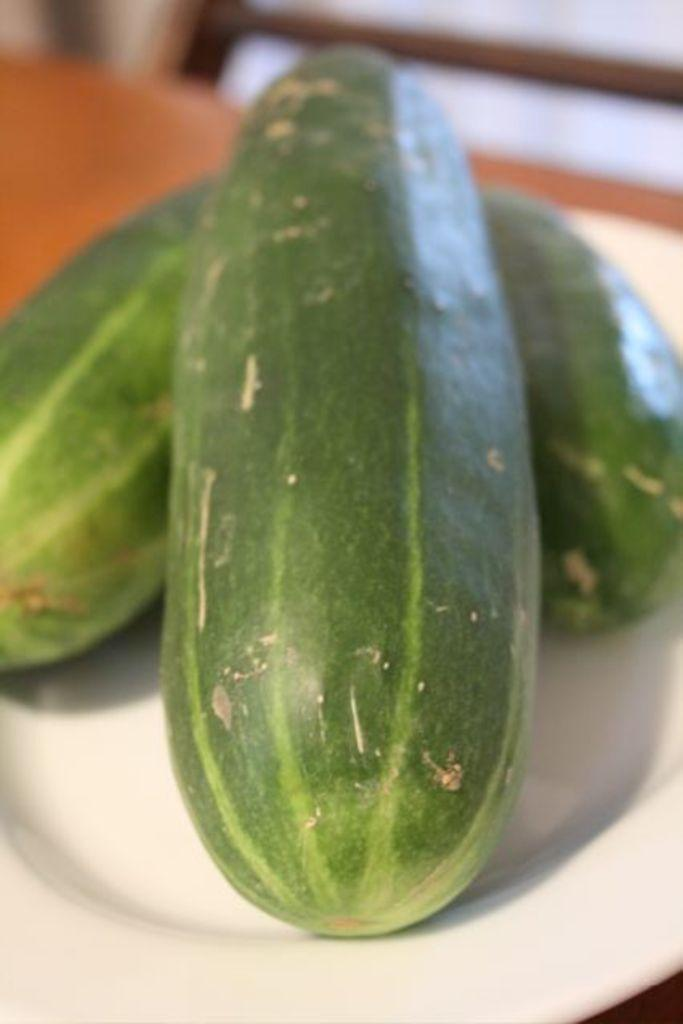What type of food is on the plate in the image? There are cucumbers on a plate in the image. Can you describe the background of the image? The background of the image is blurred. What type of chain is draped over the cucumbers in the image? There is no chain present in the image; it only features cucumbers on a plate. 